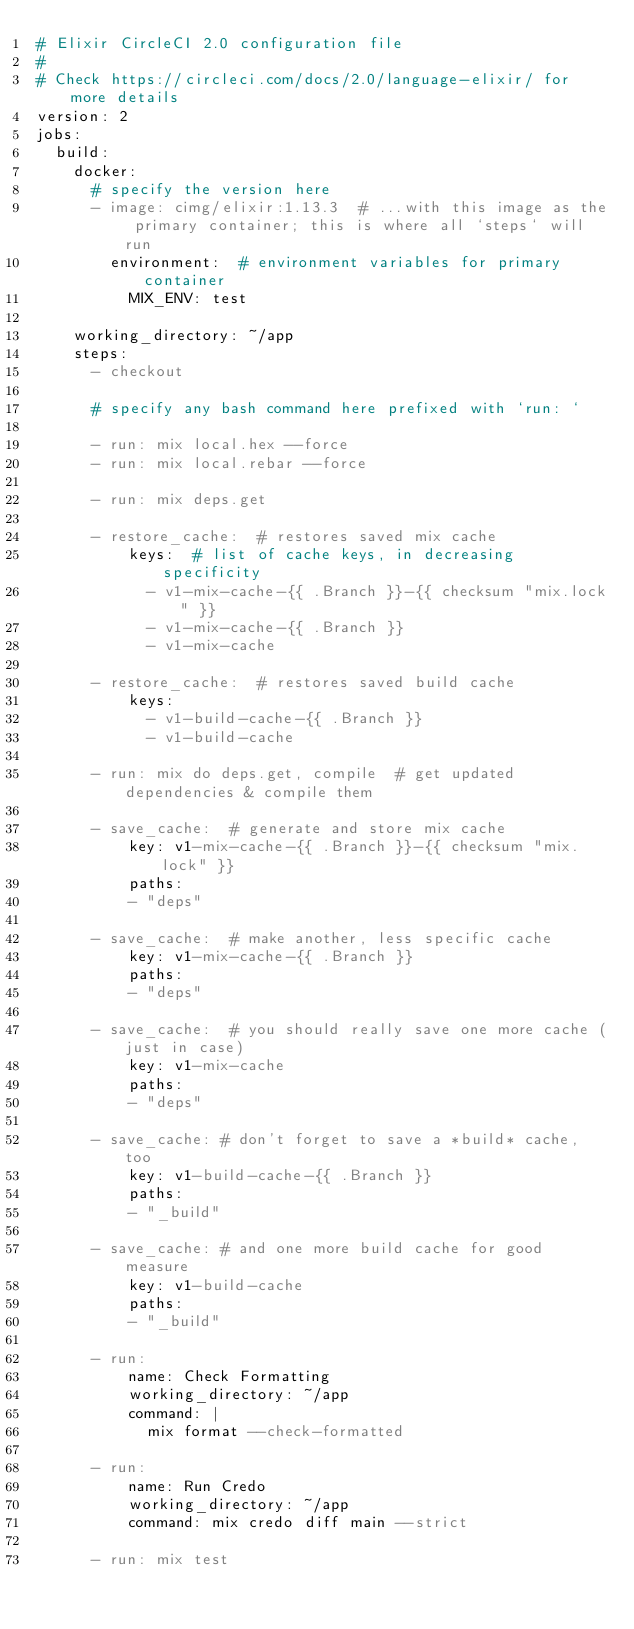Convert code to text. <code><loc_0><loc_0><loc_500><loc_500><_YAML_># Elixir CircleCI 2.0 configuration file
#
# Check https://circleci.com/docs/2.0/language-elixir/ for more details
version: 2
jobs:
  build:
    docker:
      # specify the version here
      - image: cimg/elixir:1.13.3  # ...with this image as the primary container; this is where all `steps` will run
        environment:  # environment variables for primary container
          MIX_ENV: test

    working_directory: ~/app
    steps:
      - checkout

      # specify any bash command here prefixed with `run: `

      - run: mix local.hex --force
      - run: mix local.rebar --force

      - run: mix deps.get

      - restore_cache:  # restores saved mix cache
          keys:  # list of cache keys, in decreasing specificity
            - v1-mix-cache-{{ .Branch }}-{{ checksum "mix.lock" }}
            - v1-mix-cache-{{ .Branch }}
            - v1-mix-cache

      - restore_cache:  # restores saved build cache
          keys:
            - v1-build-cache-{{ .Branch }}
            - v1-build-cache

      - run: mix do deps.get, compile  # get updated dependencies & compile them

      - save_cache:  # generate and store mix cache
          key: v1-mix-cache-{{ .Branch }}-{{ checksum "mix.lock" }}
          paths:
          - "deps"

      - save_cache:  # make another, less specific cache
          key: v1-mix-cache-{{ .Branch }}
          paths:
          - "deps"

      - save_cache:  # you should really save one more cache (just in case)
          key: v1-mix-cache
          paths:
          - "deps"

      - save_cache: # don't forget to save a *build* cache, too
          key: v1-build-cache-{{ .Branch }}
          paths:
          - "_build"

      - save_cache: # and one more build cache for good measure
          key: v1-build-cache
          paths:
          - "_build"

      - run:
          name: Check Formatting
          working_directory: ~/app
          command: |
            mix format --check-formatted

      - run:
          name: Run Credo
          working_directory: ~/app
          command: mix credo diff main --strict

      - run: mix test
</code> 